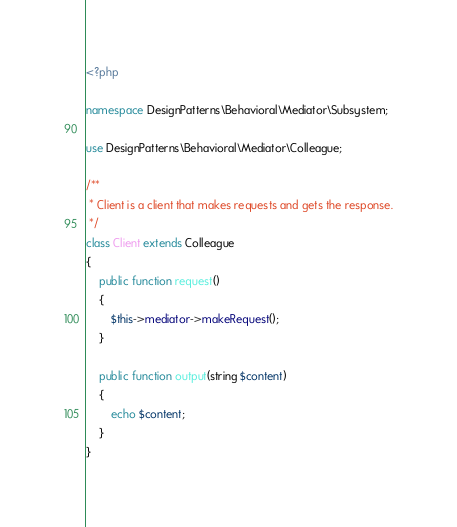Convert code to text. <code><loc_0><loc_0><loc_500><loc_500><_PHP_><?php

namespace DesignPatterns\Behavioral\Mediator\Subsystem;

use DesignPatterns\Behavioral\Mediator\Colleague;

/**
 * Client is a client that makes requests and gets the response.
 */
class Client extends Colleague
{
    public function request()
    {
        $this->mediator->makeRequest();
    }

    public function output(string $content)
    {
        echo $content;
    }
}
</code> 